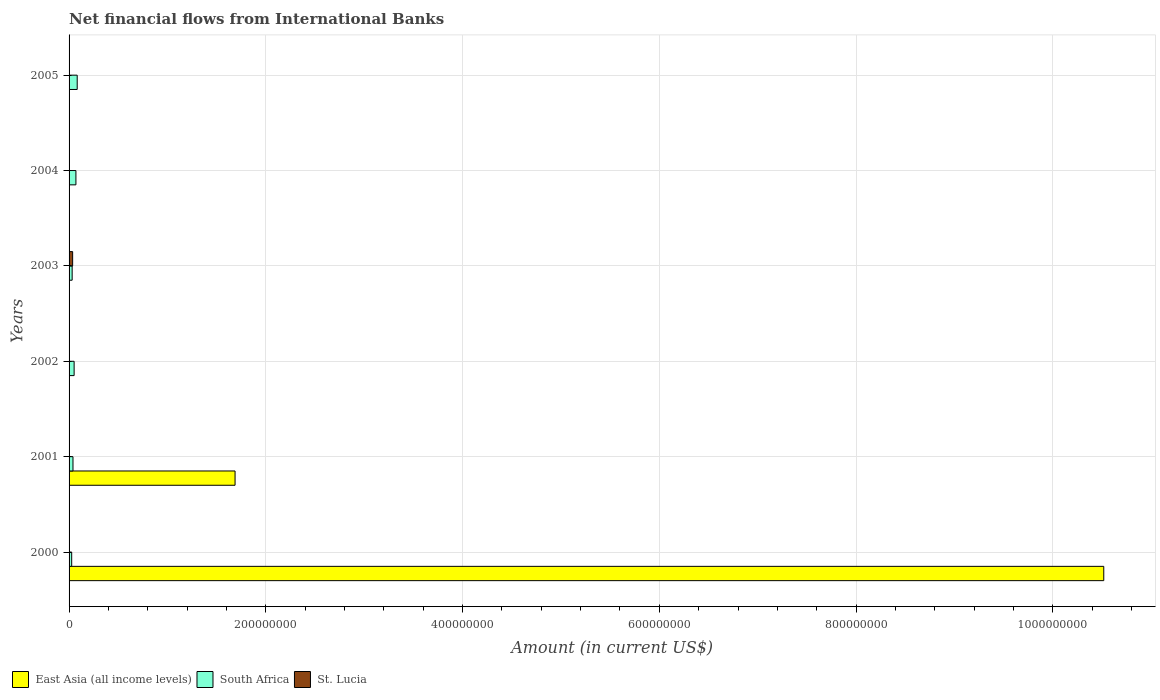How many different coloured bars are there?
Make the answer very short. 3. How many groups of bars are there?
Your answer should be compact. 6. Are the number of bars per tick equal to the number of legend labels?
Offer a terse response. No. What is the label of the 6th group of bars from the top?
Keep it short and to the point. 2000. In how many cases, is the number of bars for a given year not equal to the number of legend labels?
Offer a terse response. 5. What is the net financial aid flows in South Africa in 2004?
Ensure brevity in your answer.  6.96e+06. Across all years, what is the maximum net financial aid flows in East Asia (all income levels)?
Make the answer very short. 1.05e+09. In which year was the net financial aid flows in St. Lucia maximum?
Offer a very short reply. 2003. What is the total net financial aid flows in East Asia (all income levels) in the graph?
Offer a very short reply. 1.22e+09. What is the difference between the net financial aid flows in St. Lucia in 2004 and that in 2005?
Your answer should be very brief. 3.40e+04. What is the difference between the net financial aid flows in St. Lucia in 2003 and the net financial aid flows in East Asia (all income levels) in 2002?
Keep it short and to the point. 3.62e+06. What is the average net financial aid flows in South Africa per year?
Keep it short and to the point. 5.02e+06. In the year 2003, what is the difference between the net financial aid flows in St. Lucia and net financial aid flows in South Africa?
Provide a succinct answer. 4.88e+05. In how many years, is the net financial aid flows in St. Lucia greater than 440000000 US$?
Offer a terse response. 0. What is the ratio of the net financial aid flows in St. Lucia in 2003 to that in 2005?
Your answer should be compact. 28.75. Is the net financial aid flows in St. Lucia in 2002 less than that in 2004?
Ensure brevity in your answer.  No. What is the difference between the highest and the second highest net financial aid flows in South Africa?
Offer a terse response. 1.30e+06. What is the difference between the highest and the lowest net financial aid flows in St. Lucia?
Your answer should be very brief. 3.62e+06. In how many years, is the net financial aid flows in South Africa greater than the average net financial aid flows in South Africa taken over all years?
Give a very brief answer. 3. Is the sum of the net financial aid flows in South Africa in 2000 and 2005 greater than the maximum net financial aid flows in St. Lucia across all years?
Your answer should be very brief. Yes. Is it the case that in every year, the sum of the net financial aid flows in South Africa and net financial aid flows in East Asia (all income levels) is greater than the net financial aid flows in St. Lucia?
Offer a terse response. No. How many bars are there?
Your response must be concise. 13. How are the legend labels stacked?
Your answer should be very brief. Horizontal. What is the title of the graph?
Provide a succinct answer. Net financial flows from International Banks. Does "Azerbaijan" appear as one of the legend labels in the graph?
Your response must be concise. No. What is the label or title of the Y-axis?
Provide a succinct answer. Years. What is the Amount (in current US$) of East Asia (all income levels) in 2000?
Make the answer very short. 1.05e+09. What is the Amount (in current US$) of South Africa in 2000?
Make the answer very short. 2.66e+06. What is the Amount (in current US$) in St. Lucia in 2000?
Keep it short and to the point. 3.62e+05. What is the Amount (in current US$) of East Asia (all income levels) in 2001?
Offer a very short reply. 1.69e+08. What is the Amount (in current US$) in South Africa in 2001?
Offer a terse response. 3.98e+06. What is the Amount (in current US$) in East Asia (all income levels) in 2002?
Give a very brief answer. 0. What is the Amount (in current US$) in South Africa in 2002?
Make the answer very short. 5.14e+06. What is the Amount (in current US$) in St. Lucia in 2002?
Ensure brevity in your answer.  3.21e+05. What is the Amount (in current US$) in East Asia (all income levels) in 2003?
Your answer should be very brief. 0. What is the Amount (in current US$) of South Africa in 2003?
Keep it short and to the point. 3.14e+06. What is the Amount (in current US$) in St. Lucia in 2003?
Your response must be concise. 3.62e+06. What is the Amount (in current US$) of East Asia (all income levels) in 2004?
Ensure brevity in your answer.  0. What is the Amount (in current US$) in South Africa in 2004?
Keep it short and to the point. 6.96e+06. What is the Amount (in current US$) of St. Lucia in 2004?
Provide a succinct answer. 1.60e+05. What is the Amount (in current US$) of East Asia (all income levels) in 2005?
Your response must be concise. 0. What is the Amount (in current US$) of South Africa in 2005?
Make the answer very short. 8.26e+06. What is the Amount (in current US$) in St. Lucia in 2005?
Give a very brief answer. 1.26e+05. Across all years, what is the maximum Amount (in current US$) of East Asia (all income levels)?
Your answer should be very brief. 1.05e+09. Across all years, what is the maximum Amount (in current US$) in South Africa?
Provide a succinct answer. 8.26e+06. Across all years, what is the maximum Amount (in current US$) in St. Lucia?
Keep it short and to the point. 3.62e+06. Across all years, what is the minimum Amount (in current US$) of South Africa?
Offer a terse response. 2.66e+06. What is the total Amount (in current US$) in East Asia (all income levels) in the graph?
Offer a very short reply. 1.22e+09. What is the total Amount (in current US$) in South Africa in the graph?
Give a very brief answer. 3.01e+07. What is the total Amount (in current US$) of St. Lucia in the graph?
Offer a very short reply. 4.59e+06. What is the difference between the Amount (in current US$) in East Asia (all income levels) in 2000 and that in 2001?
Offer a very short reply. 8.83e+08. What is the difference between the Amount (in current US$) in South Africa in 2000 and that in 2001?
Your response must be concise. -1.32e+06. What is the difference between the Amount (in current US$) in South Africa in 2000 and that in 2002?
Your answer should be compact. -2.48e+06. What is the difference between the Amount (in current US$) of St. Lucia in 2000 and that in 2002?
Provide a succinct answer. 4.10e+04. What is the difference between the Amount (in current US$) of South Africa in 2000 and that in 2003?
Keep it short and to the point. -4.74e+05. What is the difference between the Amount (in current US$) of St. Lucia in 2000 and that in 2003?
Your answer should be compact. -3.26e+06. What is the difference between the Amount (in current US$) in South Africa in 2000 and that in 2004?
Make the answer very short. -4.30e+06. What is the difference between the Amount (in current US$) in St. Lucia in 2000 and that in 2004?
Provide a succinct answer. 2.02e+05. What is the difference between the Amount (in current US$) in South Africa in 2000 and that in 2005?
Your response must be concise. -5.60e+06. What is the difference between the Amount (in current US$) in St. Lucia in 2000 and that in 2005?
Your answer should be very brief. 2.36e+05. What is the difference between the Amount (in current US$) of South Africa in 2001 and that in 2002?
Keep it short and to the point. -1.16e+06. What is the difference between the Amount (in current US$) in South Africa in 2001 and that in 2003?
Make the answer very short. 8.50e+05. What is the difference between the Amount (in current US$) of South Africa in 2001 and that in 2004?
Make the answer very short. -2.98e+06. What is the difference between the Amount (in current US$) of South Africa in 2001 and that in 2005?
Ensure brevity in your answer.  -4.28e+06. What is the difference between the Amount (in current US$) in South Africa in 2002 and that in 2003?
Give a very brief answer. 2.01e+06. What is the difference between the Amount (in current US$) of St. Lucia in 2002 and that in 2003?
Provide a succinct answer. -3.30e+06. What is the difference between the Amount (in current US$) of South Africa in 2002 and that in 2004?
Your response must be concise. -1.82e+06. What is the difference between the Amount (in current US$) of St. Lucia in 2002 and that in 2004?
Offer a terse response. 1.61e+05. What is the difference between the Amount (in current US$) of South Africa in 2002 and that in 2005?
Offer a very short reply. -3.12e+06. What is the difference between the Amount (in current US$) in St. Lucia in 2002 and that in 2005?
Provide a succinct answer. 1.95e+05. What is the difference between the Amount (in current US$) in South Africa in 2003 and that in 2004?
Give a very brief answer. -3.83e+06. What is the difference between the Amount (in current US$) in St. Lucia in 2003 and that in 2004?
Your response must be concise. 3.46e+06. What is the difference between the Amount (in current US$) in South Africa in 2003 and that in 2005?
Your answer should be compact. -5.12e+06. What is the difference between the Amount (in current US$) in St. Lucia in 2003 and that in 2005?
Keep it short and to the point. 3.50e+06. What is the difference between the Amount (in current US$) in South Africa in 2004 and that in 2005?
Your answer should be compact. -1.30e+06. What is the difference between the Amount (in current US$) in St. Lucia in 2004 and that in 2005?
Provide a succinct answer. 3.40e+04. What is the difference between the Amount (in current US$) in East Asia (all income levels) in 2000 and the Amount (in current US$) in South Africa in 2001?
Give a very brief answer. 1.05e+09. What is the difference between the Amount (in current US$) of East Asia (all income levels) in 2000 and the Amount (in current US$) of South Africa in 2002?
Keep it short and to the point. 1.05e+09. What is the difference between the Amount (in current US$) in East Asia (all income levels) in 2000 and the Amount (in current US$) in St. Lucia in 2002?
Your answer should be very brief. 1.05e+09. What is the difference between the Amount (in current US$) of South Africa in 2000 and the Amount (in current US$) of St. Lucia in 2002?
Provide a short and direct response. 2.34e+06. What is the difference between the Amount (in current US$) of East Asia (all income levels) in 2000 and the Amount (in current US$) of South Africa in 2003?
Keep it short and to the point. 1.05e+09. What is the difference between the Amount (in current US$) in East Asia (all income levels) in 2000 and the Amount (in current US$) in St. Lucia in 2003?
Your answer should be very brief. 1.05e+09. What is the difference between the Amount (in current US$) in South Africa in 2000 and the Amount (in current US$) in St. Lucia in 2003?
Your answer should be very brief. -9.62e+05. What is the difference between the Amount (in current US$) of East Asia (all income levels) in 2000 and the Amount (in current US$) of South Africa in 2004?
Offer a very short reply. 1.04e+09. What is the difference between the Amount (in current US$) in East Asia (all income levels) in 2000 and the Amount (in current US$) in St. Lucia in 2004?
Give a very brief answer. 1.05e+09. What is the difference between the Amount (in current US$) in South Africa in 2000 and the Amount (in current US$) in St. Lucia in 2004?
Offer a very short reply. 2.50e+06. What is the difference between the Amount (in current US$) in East Asia (all income levels) in 2000 and the Amount (in current US$) in South Africa in 2005?
Your answer should be compact. 1.04e+09. What is the difference between the Amount (in current US$) in East Asia (all income levels) in 2000 and the Amount (in current US$) in St. Lucia in 2005?
Provide a succinct answer. 1.05e+09. What is the difference between the Amount (in current US$) in South Africa in 2000 and the Amount (in current US$) in St. Lucia in 2005?
Provide a succinct answer. 2.54e+06. What is the difference between the Amount (in current US$) of East Asia (all income levels) in 2001 and the Amount (in current US$) of South Africa in 2002?
Offer a very short reply. 1.64e+08. What is the difference between the Amount (in current US$) of East Asia (all income levels) in 2001 and the Amount (in current US$) of St. Lucia in 2002?
Keep it short and to the point. 1.68e+08. What is the difference between the Amount (in current US$) of South Africa in 2001 and the Amount (in current US$) of St. Lucia in 2002?
Offer a terse response. 3.66e+06. What is the difference between the Amount (in current US$) in East Asia (all income levels) in 2001 and the Amount (in current US$) in South Africa in 2003?
Offer a terse response. 1.66e+08. What is the difference between the Amount (in current US$) in East Asia (all income levels) in 2001 and the Amount (in current US$) in St. Lucia in 2003?
Make the answer very short. 1.65e+08. What is the difference between the Amount (in current US$) of South Africa in 2001 and the Amount (in current US$) of St. Lucia in 2003?
Your answer should be compact. 3.62e+05. What is the difference between the Amount (in current US$) of East Asia (all income levels) in 2001 and the Amount (in current US$) of South Africa in 2004?
Offer a very short reply. 1.62e+08. What is the difference between the Amount (in current US$) in East Asia (all income levels) in 2001 and the Amount (in current US$) in St. Lucia in 2004?
Provide a short and direct response. 1.69e+08. What is the difference between the Amount (in current US$) in South Africa in 2001 and the Amount (in current US$) in St. Lucia in 2004?
Offer a terse response. 3.82e+06. What is the difference between the Amount (in current US$) in East Asia (all income levels) in 2001 and the Amount (in current US$) in South Africa in 2005?
Offer a terse response. 1.60e+08. What is the difference between the Amount (in current US$) in East Asia (all income levels) in 2001 and the Amount (in current US$) in St. Lucia in 2005?
Offer a terse response. 1.69e+08. What is the difference between the Amount (in current US$) in South Africa in 2001 and the Amount (in current US$) in St. Lucia in 2005?
Offer a terse response. 3.86e+06. What is the difference between the Amount (in current US$) of South Africa in 2002 and the Amount (in current US$) of St. Lucia in 2003?
Ensure brevity in your answer.  1.52e+06. What is the difference between the Amount (in current US$) in South Africa in 2002 and the Amount (in current US$) in St. Lucia in 2004?
Give a very brief answer. 4.98e+06. What is the difference between the Amount (in current US$) in South Africa in 2002 and the Amount (in current US$) in St. Lucia in 2005?
Offer a terse response. 5.02e+06. What is the difference between the Amount (in current US$) in South Africa in 2003 and the Amount (in current US$) in St. Lucia in 2004?
Offer a very short reply. 2.98e+06. What is the difference between the Amount (in current US$) in South Africa in 2003 and the Amount (in current US$) in St. Lucia in 2005?
Ensure brevity in your answer.  3.01e+06. What is the difference between the Amount (in current US$) of South Africa in 2004 and the Amount (in current US$) of St. Lucia in 2005?
Ensure brevity in your answer.  6.84e+06. What is the average Amount (in current US$) in East Asia (all income levels) per year?
Provide a short and direct response. 2.03e+08. What is the average Amount (in current US$) of South Africa per year?
Your answer should be compact. 5.02e+06. What is the average Amount (in current US$) of St. Lucia per year?
Your answer should be compact. 7.65e+05. In the year 2000, what is the difference between the Amount (in current US$) in East Asia (all income levels) and Amount (in current US$) in South Africa?
Offer a terse response. 1.05e+09. In the year 2000, what is the difference between the Amount (in current US$) of East Asia (all income levels) and Amount (in current US$) of St. Lucia?
Your answer should be very brief. 1.05e+09. In the year 2000, what is the difference between the Amount (in current US$) of South Africa and Amount (in current US$) of St. Lucia?
Offer a terse response. 2.30e+06. In the year 2001, what is the difference between the Amount (in current US$) of East Asia (all income levels) and Amount (in current US$) of South Africa?
Offer a terse response. 1.65e+08. In the year 2002, what is the difference between the Amount (in current US$) of South Africa and Amount (in current US$) of St. Lucia?
Your answer should be compact. 4.82e+06. In the year 2003, what is the difference between the Amount (in current US$) of South Africa and Amount (in current US$) of St. Lucia?
Make the answer very short. -4.88e+05. In the year 2004, what is the difference between the Amount (in current US$) of South Africa and Amount (in current US$) of St. Lucia?
Give a very brief answer. 6.80e+06. In the year 2005, what is the difference between the Amount (in current US$) of South Africa and Amount (in current US$) of St. Lucia?
Ensure brevity in your answer.  8.13e+06. What is the ratio of the Amount (in current US$) of East Asia (all income levels) in 2000 to that in 2001?
Provide a short and direct response. 6.23. What is the ratio of the Amount (in current US$) in South Africa in 2000 to that in 2001?
Ensure brevity in your answer.  0.67. What is the ratio of the Amount (in current US$) of South Africa in 2000 to that in 2002?
Offer a very short reply. 0.52. What is the ratio of the Amount (in current US$) of St. Lucia in 2000 to that in 2002?
Make the answer very short. 1.13. What is the ratio of the Amount (in current US$) of South Africa in 2000 to that in 2003?
Provide a succinct answer. 0.85. What is the ratio of the Amount (in current US$) in St. Lucia in 2000 to that in 2003?
Your answer should be very brief. 0.1. What is the ratio of the Amount (in current US$) of South Africa in 2000 to that in 2004?
Offer a terse response. 0.38. What is the ratio of the Amount (in current US$) of St. Lucia in 2000 to that in 2004?
Offer a very short reply. 2.26. What is the ratio of the Amount (in current US$) of South Africa in 2000 to that in 2005?
Your response must be concise. 0.32. What is the ratio of the Amount (in current US$) in St. Lucia in 2000 to that in 2005?
Offer a terse response. 2.87. What is the ratio of the Amount (in current US$) of South Africa in 2001 to that in 2002?
Ensure brevity in your answer.  0.78. What is the ratio of the Amount (in current US$) of South Africa in 2001 to that in 2003?
Provide a succinct answer. 1.27. What is the ratio of the Amount (in current US$) of South Africa in 2001 to that in 2004?
Keep it short and to the point. 0.57. What is the ratio of the Amount (in current US$) of South Africa in 2001 to that in 2005?
Your answer should be very brief. 0.48. What is the ratio of the Amount (in current US$) in South Africa in 2002 to that in 2003?
Ensure brevity in your answer.  1.64. What is the ratio of the Amount (in current US$) in St. Lucia in 2002 to that in 2003?
Provide a short and direct response. 0.09. What is the ratio of the Amount (in current US$) in South Africa in 2002 to that in 2004?
Keep it short and to the point. 0.74. What is the ratio of the Amount (in current US$) of St. Lucia in 2002 to that in 2004?
Your answer should be very brief. 2.01. What is the ratio of the Amount (in current US$) in South Africa in 2002 to that in 2005?
Offer a very short reply. 0.62. What is the ratio of the Amount (in current US$) in St. Lucia in 2002 to that in 2005?
Offer a terse response. 2.55. What is the ratio of the Amount (in current US$) in South Africa in 2003 to that in 2004?
Give a very brief answer. 0.45. What is the ratio of the Amount (in current US$) in St. Lucia in 2003 to that in 2004?
Offer a very short reply. 22.64. What is the ratio of the Amount (in current US$) in South Africa in 2003 to that in 2005?
Provide a succinct answer. 0.38. What is the ratio of the Amount (in current US$) in St. Lucia in 2003 to that in 2005?
Offer a terse response. 28.75. What is the ratio of the Amount (in current US$) in South Africa in 2004 to that in 2005?
Provide a short and direct response. 0.84. What is the ratio of the Amount (in current US$) of St. Lucia in 2004 to that in 2005?
Provide a short and direct response. 1.27. What is the difference between the highest and the second highest Amount (in current US$) in South Africa?
Your response must be concise. 1.30e+06. What is the difference between the highest and the second highest Amount (in current US$) of St. Lucia?
Make the answer very short. 3.26e+06. What is the difference between the highest and the lowest Amount (in current US$) in East Asia (all income levels)?
Make the answer very short. 1.05e+09. What is the difference between the highest and the lowest Amount (in current US$) of South Africa?
Provide a short and direct response. 5.60e+06. What is the difference between the highest and the lowest Amount (in current US$) in St. Lucia?
Provide a succinct answer. 3.62e+06. 